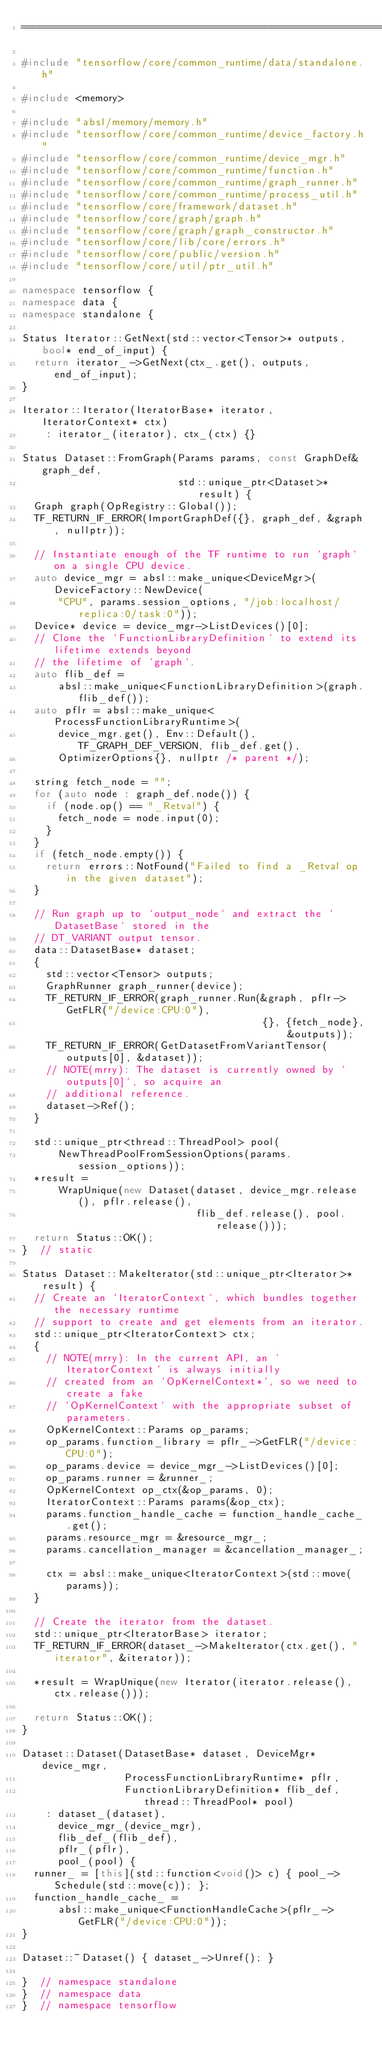Convert code to text. <code><loc_0><loc_0><loc_500><loc_500><_C++_>==============================================================================*/

#include "tensorflow/core/common_runtime/data/standalone.h"

#include <memory>

#include "absl/memory/memory.h"
#include "tensorflow/core/common_runtime/device_factory.h"
#include "tensorflow/core/common_runtime/device_mgr.h"
#include "tensorflow/core/common_runtime/function.h"
#include "tensorflow/core/common_runtime/graph_runner.h"
#include "tensorflow/core/common_runtime/process_util.h"
#include "tensorflow/core/framework/dataset.h"
#include "tensorflow/core/graph/graph.h"
#include "tensorflow/core/graph/graph_constructor.h"
#include "tensorflow/core/lib/core/errors.h"
#include "tensorflow/core/public/version.h"
#include "tensorflow/core/util/ptr_util.h"

namespace tensorflow {
namespace data {
namespace standalone {

Status Iterator::GetNext(std::vector<Tensor>* outputs, bool* end_of_input) {
  return iterator_->GetNext(ctx_.get(), outputs, end_of_input);
}

Iterator::Iterator(IteratorBase* iterator, IteratorContext* ctx)
    : iterator_(iterator), ctx_(ctx) {}

Status Dataset::FromGraph(Params params, const GraphDef& graph_def,
                          std::unique_ptr<Dataset>* result) {
  Graph graph(OpRegistry::Global());
  TF_RETURN_IF_ERROR(ImportGraphDef({}, graph_def, &graph, nullptr));

  // Instantiate enough of the TF runtime to run `graph` on a single CPU device.
  auto device_mgr = absl::make_unique<DeviceMgr>(DeviceFactory::NewDevice(
      "CPU", params.session_options, "/job:localhost/replica:0/task:0"));
  Device* device = device_mgr->ListDevices()[0];
  // Clone the `FunctionLibraryDefinition` to extend its lifetime extends beyond
  // the lifetime of `graph`.
  auto flib_def =
      absl::make_unique<FunctionLibraryDefinition>(graph.flib_def());
  auto pflr = absl::make_unique<ProcessFunctionLibraryRuntime>(
      device_mgr.get(), Env::Default(), TF_GRAPH_DEF_VERSION, flib_def.get(),
      OptimizerOptions{}, nullptr /* parent */);

  string fetch_node = "";
  for (auto node : graph_def.node()) {
    if (node.op() == "_Retval") {
      fetch_node = node.input(0);
    }
  }
  if (fetch_node.empty()) {
    return errors::NotFound("Failed to find a _Retval op in the given dataset");
  }

  // Run graph up to `output_node` and extract the `DatasetBase` stored in the
  // DT_VARIANT output tensor.
  data::DatasetBase* dataset;
  {
    std::vector<Tensor> outputs;
    GraphRunner graph_runner(device);
    TF_RETURN_IF_ERROR(graph_runner.Run(&graph, pflr->GetFLR("/device:CPU:0"),
                                        {}, {fetch_node}, &outputs));
    TF_RETURN_IF_ERROR(GetDatasetFromVariantTensor(outputs[0], &dataset));
    // NOTE(mrry): The dataset is currently owned by `outputs[0]`, so acquire an
    // additional reference.
    dataset->Ref();
  }

  std::unique_ptr<thread::ThreadPool> pool(
      NewThreadPoolFromSessionOptions(params.session_options));
  *result =
      WrapUnique(new Dataset(dataset, device_mgr.release(), pflr.release(),
                             flib_def.release(), pool.release()));
  return Status::OK();
}  // static

Status Dataset::MakeIterator(std::unique_ptr<Iterator>* result) {
  // Create an `IteratorContext`, which bundles together the necessary runtime
  // support to create and get elements from an iterator.
  std::unique_ptr<IteratorContext> ctx;
  {
    // NOTE(mrry): In the current API, an `IteratorContext` is always initially
    // created from an `OpKernelContext*`, so we need to create a fake
    // `OpKernelContext` with the appropriate subset of parameters.
    OpKernelContext::Params op_params;
    op_params.function_library = pflr_->GetFLR("/device:CPU:0");
    op_params.device = device_mgr_->ListDevices()[0];
    op_params.runner = &runner_;
    OpKernelContext op_ctx(&op_params, 0);
    IteratorContext::Params params(&op_ctx);
    params.function_handle_cache = function_handle_cache_.get();
    params.resource_mgr = &resource_mgr_;
    params.cancellation_manager = &cancellation_manager_;

    ctx = absl::make_unique<IteratorContext>(std::move(params));
  }

  // Create the iterator from the dataset.
  std::unique_ptr<IteratorBase> iterator;
  TF_RETURN_IF_ERROR(dataset_->MakeIterator(ctx.get(), "iterator", &iterator));

  *result = WrapUnique(new Iterator(iterator.release(), ctx.release()));

  return Status::OK();
}

Dataset::Dataset(DatasetBase* dataset, DeviceMgr* device_mgr,
                 ProcessFunctionLibraryRuntime* pflr,
                 FunctionLibraryDefinition* flib_def, thread::ThreadPool* pool)
    : dataset_(dataset),
      device_mgr_(device_mgr),
      flib_def_(flib_def),
      pflr_(pflr),
      pool_(pool) {
  runner_ = [this](std::function<void()> c) { pool_->Schedule(std::move(c)); };
  function_handle_cache_ =
      absl::make_unique<FunctionHandleCache>(pflr_->GetFLR("/device:CPU:0"));
}

Dataset::~Dataset() { dataset_->Unref(); }

}  // namespace standalone
}  // namespace data
}  // namespace tensorflow
</code> 